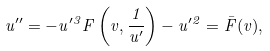<formula> <loc_0><loc_0><loc_500><loc_500>u ^ { \prime \prime } = - u ^ { \prime 3 } F \left ( v , \frac { 1 } { u ^ { \prime } } \right ) - u ^ { \prime 2 } = \bar { F } ( v ) ,</formula> 